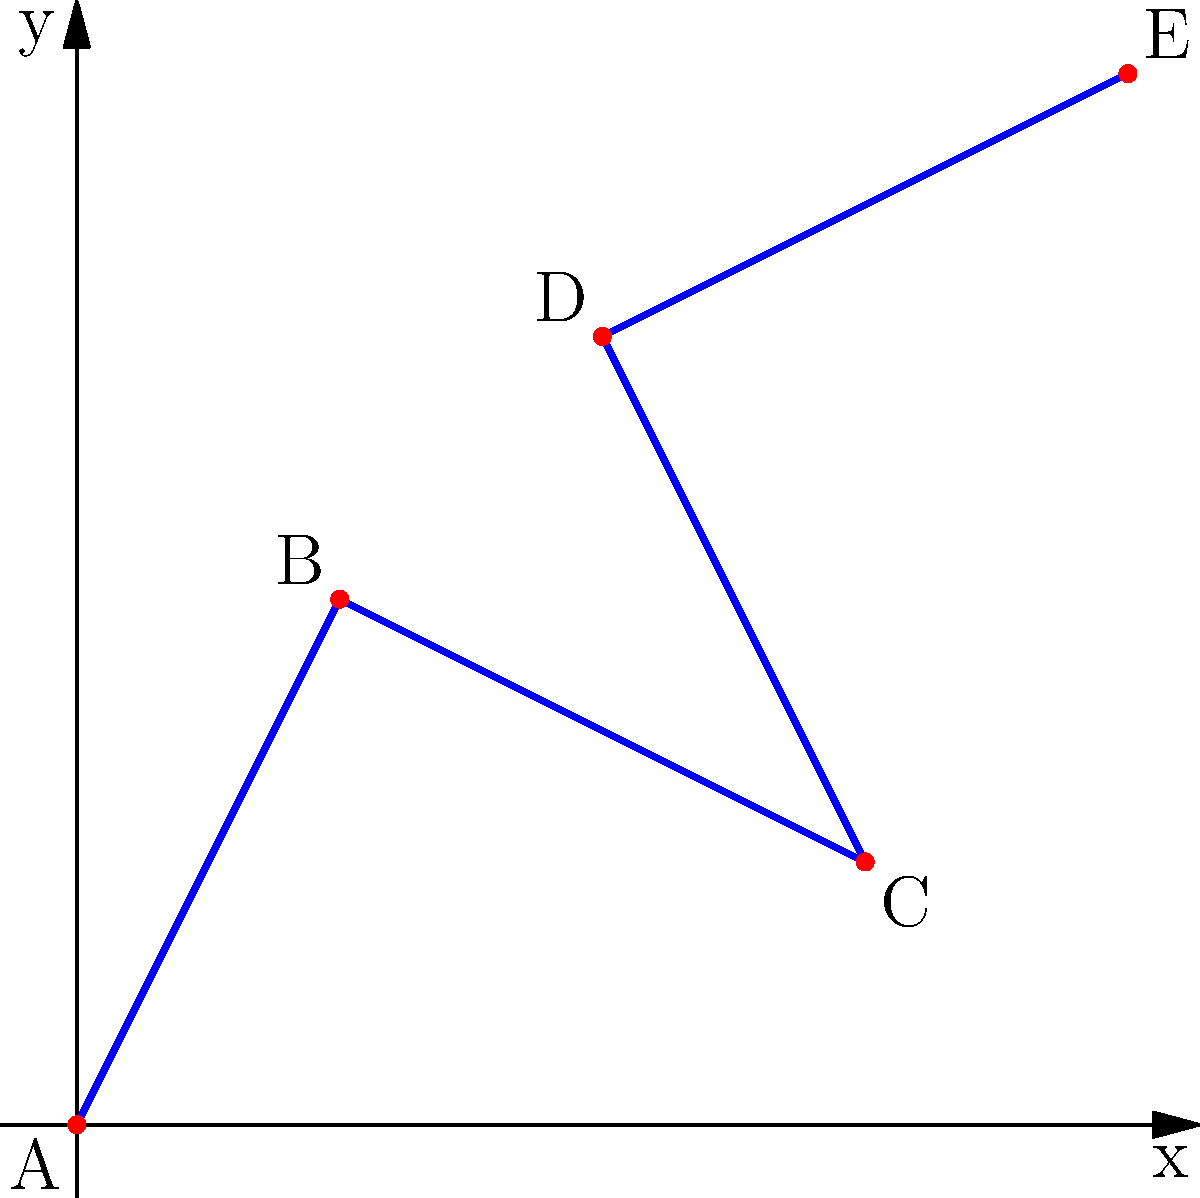In a visual perception test, a patient's eye movement is tracked on a 2D coordinate grid. The path of the eye movement is shown in the graph, starting at point A (0,0) and ending at point E (4,4). What is the total distance traveled by the eye, rounded to two decimal places? To calculate the total distance traveled by the eye, we need to sum up the distances between consecutive points on the path. We can use the distance formula between two points: $d = \sqrt{(x_2-x_1)^2 + (y_2-y_1)^2}$

Let's calculate the distance for each segment:

1. A(0,0) to B(1,2):
   $d_{AB} = \sqrt{(1-0)^2 + (2-0)^2} = \sqrt{1 + 4} = \sqrt{5}$

2. B(1,2) to C(3,1):
   $d_{BC} = \sqrt{(3-1)^2 + (1-2)^2} = \sqrt{4 + 1} = \sqrt{5}$

3. C(3,1) to D(2,3):
   $d_{CD} = \sqrt{(2-3)^2 + (3-1)^2} = \sqrt{1 + 4} = \sqrt{5}$

4. D(2,3) to E(4,4):
   $d_{DE} = \sqrt{(4-2)^2 + (4-3)^2} = \sqrt{4 + 1} = \sqrt{5}$

Now, let's sum up all these distances:

Total distance = $d_{AB} + d_{BC} + d_{CD} + d_{DE}$
               = $\sqrt{5} + \sqrt{5} + \sqrt{5} + \sqrt{5}$
               = $4\sqrt{5}$

To get the numerical value, we calculate:
$4\sqrt{5} \approx 4 \times 2.236 = 8.944$

Rounding to two decimal places: 8.94
Answer: 8.94 